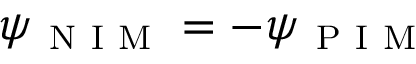Convert formula to latex. <formula><loc_0><loc_0><loc_500><loc_500>\psi _ { N I M } = - \psi _ { P I M }</formula> 